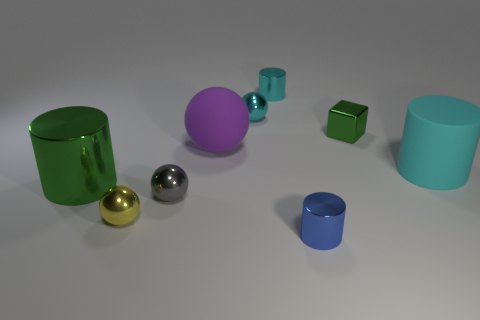Subtract 2 spheres. How many spheres are left? 2 Subtract all green cylinders. How many cylinders are left? 3 Subtract all metal spheres. How many spheres are left? 1 Add 1 matte objects. How many objects exist? 10 Subtract all red cylinders. Subtract all yellow cubes. How many cylinders are left? 4 Subtract 0 brown cylinders. How many objects are left? 9 Subtract all cubes. How many objects are left? 8 Subtract all small blue things. Subtract all cyan shiny objects. How many objects are left? 6 Add 8 rubber objects. How many rubber objects are left? 10 Add 9 large blue metal things. How many large blue metal things exist? 9 